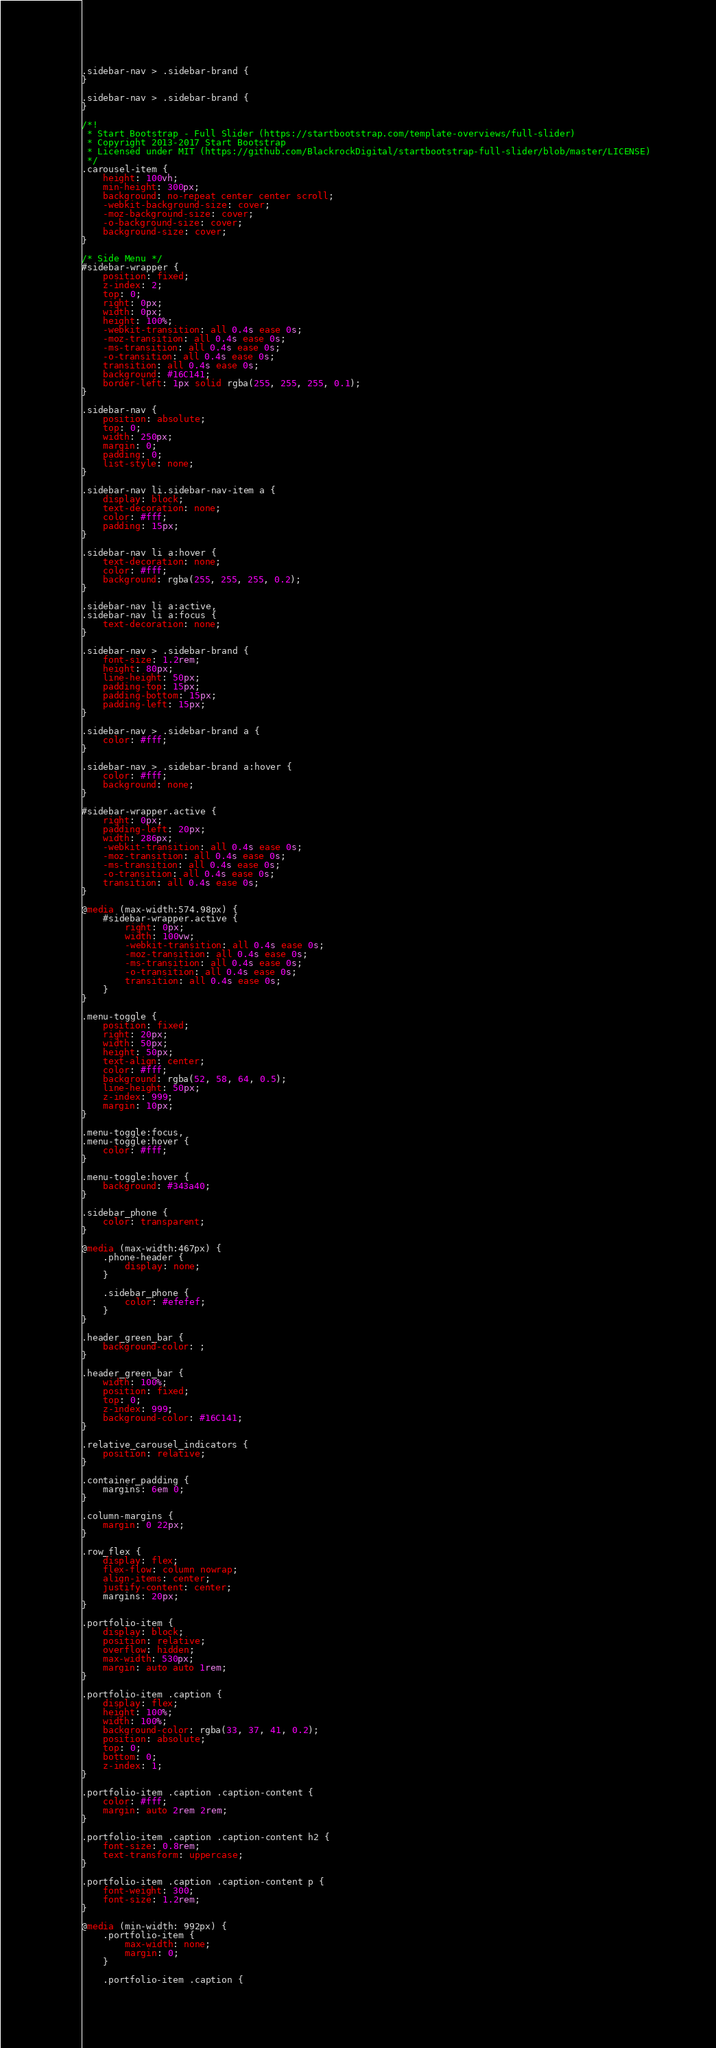<code> <loc_0><loc_0><loc_500><loc_500><_CSS_>.sidebar-nav > .sidebar-brand {
}

.sidebar-nav > .sidebar-brand {
}

/*!
 * Start Bootstrap - Full Slider (https://startbootstrap.com/template-overviews/full-slider)
 * Copyright 2013-2017 Start Bootstrap
 * Licensed under MIT (https://github.com/BlackrockDigital/startbootstrap-full-slider/blob/master/LICENSE)
 */
.carousel-item {
    height: 100vh;
    min-height: 300px;
    background: no-repeat center center scroll;
    -webkit-background-size: cover;
    -moz-background-size: cover;
    -o-background-size: cover;
    background-size: cover;
}

/* Side Menu */
#sidebar-wrapper {
    position: fixed;
    z-index: 2;
    top: 0;
    right: 0px;
    width: 0px;
    height: 100%;
    -webkit-transition: all 0.4s ease 0s;
    -moz-transition: all 0.4s ease 0s;
    -ms-transition: all 0.4s ease 0s;
    -o-transition: all 0.4s ease 0s;
    transition: all 0.4s ease 0s;
    background: #16C141;
    border-left: 1px solid rgba(255, 255, 255, 0.1);
}

.sidebar-nav {
    position: absolute;
    top: 0;
    width: 250px;
    margin: 0;
    padding: 0;
    list-style: none;
}

.sidebar-nav li.sidebar-nav-item a {
    display: block;
    text-decoration: none;
    color: #fff;
    padding: 15px;
}

.sidebar-nav li a:hover {
    text-decoration: none;
    color: #fff;
    background: rgba(255, 255, 255, 0.2);
}

.sidebar-nav li a:active,
.sidebar-nav li a:focus {
    text-decoration: none;
}

.sidebar-nav > .sidebar-brand {
    font-size: 1.2rem;
    height: 80px;
    line-height: 50px;
    padding-top: 15px;
    padding-bottom: 15px;
    padding-left: 15px;
}

.sidebar-nav > .sidebar-brand a {
    color: #fff;
}

.sidebar-nav > .sidebar-brand a:hover {
    color: #fff;
    background: none;
}

#sidebar-wrapper.active {
    right: 0px;
    padding-left: 20px;
    width: 286px;
    -webkit-transition: all 0.4s ease 0s;
    -moz-transition: all 0.4s ease 0s;
    -ms-transition: all 0.4s ease 0s;
    -o-transition: all 0.4s ease 0s;
    transition: all 0.4s ease 0s;
}

@media (max-width:574.98px) {
    #sidebar-wrapper.active {
        right: 0px;
        width: 100vw;
        -webkit-transition: all 0.4s ease 0s;
        -moz-transition: all 0.4s ease 0s;
        -ms-transition: all 0.4s ease 0s;
        -o-transition: all 0.4s ease 0s;
        transition: all 0.4s ease 0s;
    }
}

.menu-toggle {
    position: fixed;
    right: 20px;
    width: 50px;
    height: 50px;
    text-align: center;
    color: #fff;
    background: rgba(52, 58, 64, 0.5);
    line-height: 50px;
    z-index: 999;
    margin: 10px;
}

.menu-toggle:focus,
.menu-toggle:hover {
    color: #fff;
}

.menu-toggle:hover {
    background: #343a40;
}

.sidebar_phone {
    color: transparent;
}

@media (max-width:467px) {
    .phone-header {
        display: none;
    }

    .sidebar_phone {
        color: #efefef;
    }
}

.header_green_bar {
    background-color: ;
}

.header_green_bar {
    width: 100%;
    position: fixed;
    top: 0;
    z-index: 999;
    background-color: #16C141;
}

.relative_carousel_indicators {
    position: relative;
}

.container_padding {
    margins: 6em 0;
}

.column-margins {
    margin: 0 22px;
}

.row_flex {
    display: flex;
    flex-flow: column nowrap;
    align-items: center;
    justify-content: center;
    margins: 20px;
}

.portfolio-item {
    display: block;
    position: relative;
    overflow: hidden;
    max-width: 530px;
    margin: auto auto 1rem;
}

.portfolio-item .caption {
    display: flex;
    height: 100%;
    width: 100%;
    background-color: rgba(33, 37, 41, 0.2);
    position: absolute;
    top: 0;
    bottom: 0;
    z-index: 1;
}

.portfolio-item .caption .caption-content {
    color: #fff;
    margin: auto 2rem 2rem;
}

.portfolio-item .caption .caption-content h2 {
    font-size: 0.8rem;
    text-transform: uppercase;
}

.portfolio-item .caption .caption-content p {
    font-weight: 300;
    font-size: 1.2rem;
}

@media (min-width: 992px) {
    .portfolio-item {
        max-width: none;
        margin: 0;
    }

    .portfolio-item .caption {</code> 